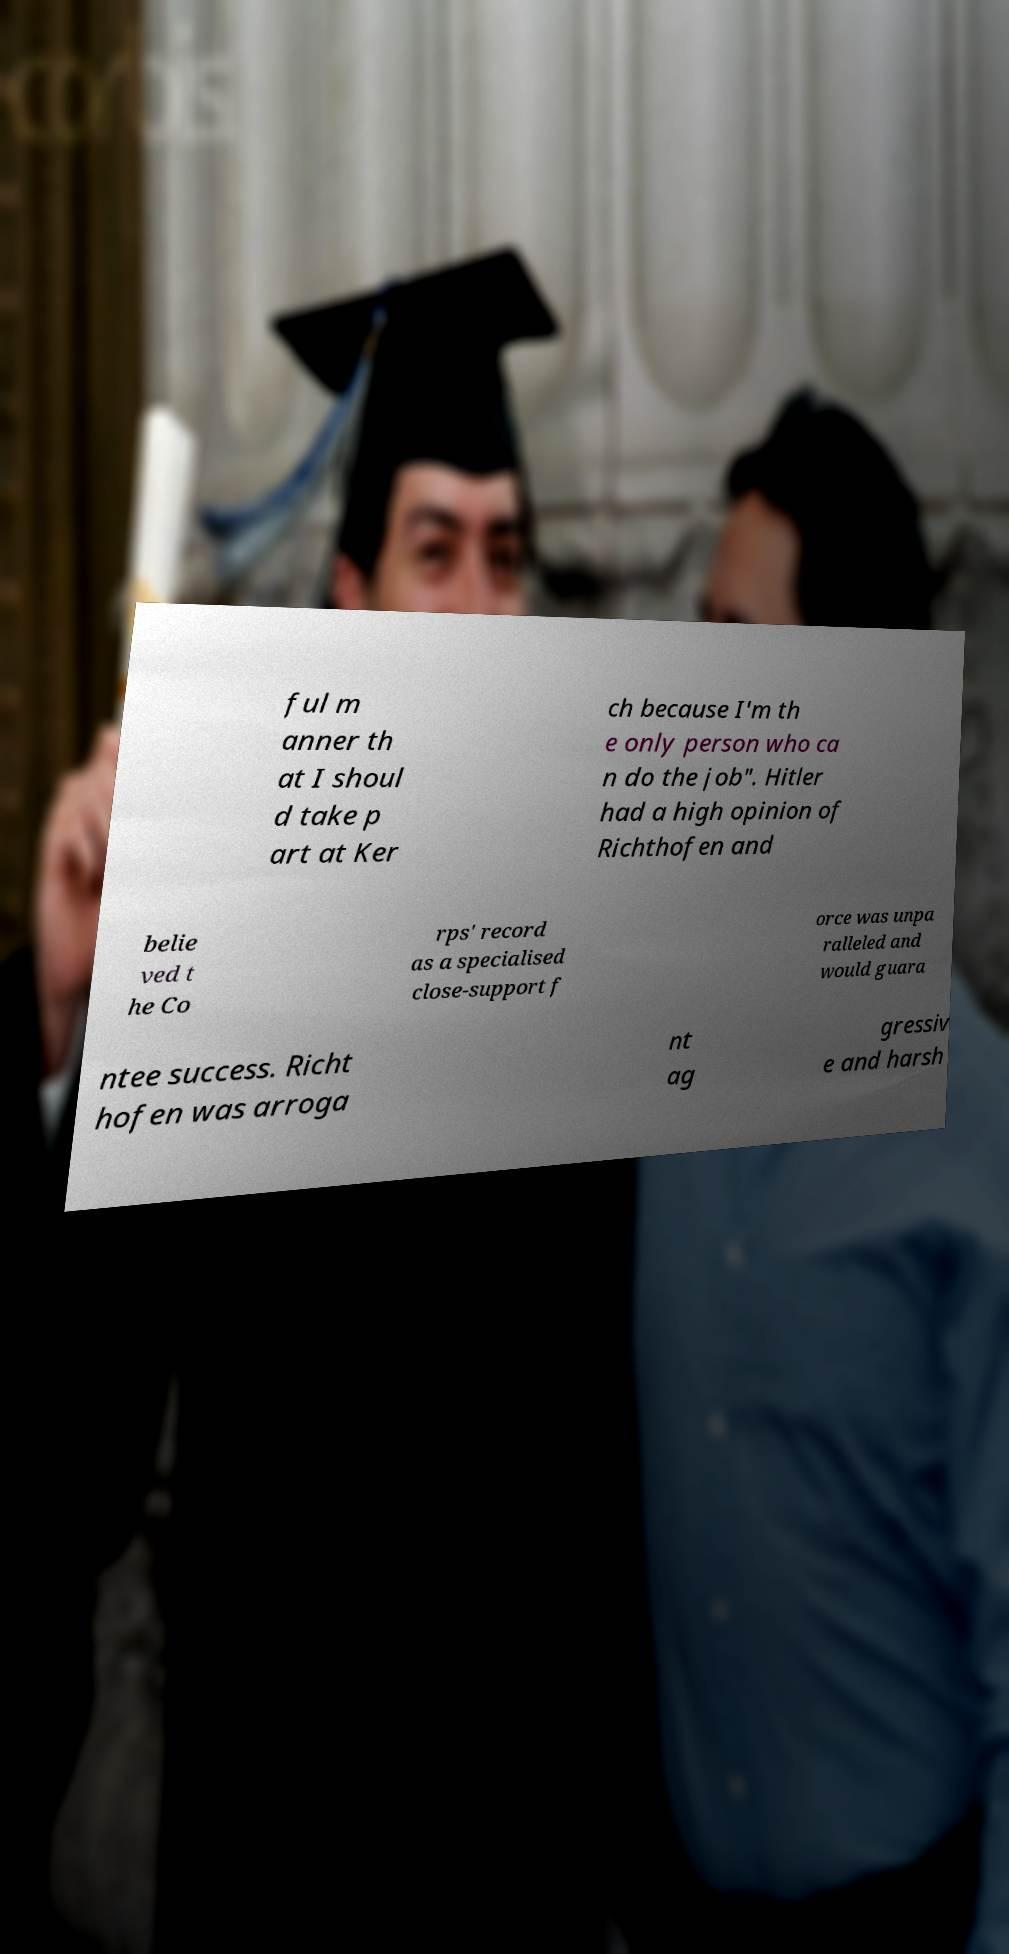Can you read and provide the text displayed in the image?This photo seems to have some interesting text. Can you extract and type it out for me? ful m anner th at I shoul d take p art at Ker ch because I'm th e only person who ca n do the job". Hitler had a high opinion of Richthofen and belie ved t he Co rps' record as a specialised close-support f orce was unpa ralleled and would guara ntee success. Richt hofen was arroga nt ag gressiv e and harsh 